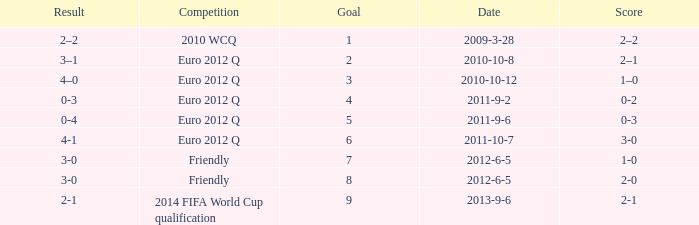How many goals when the score is 3-0 in the euro 2012 q? 1.0. 